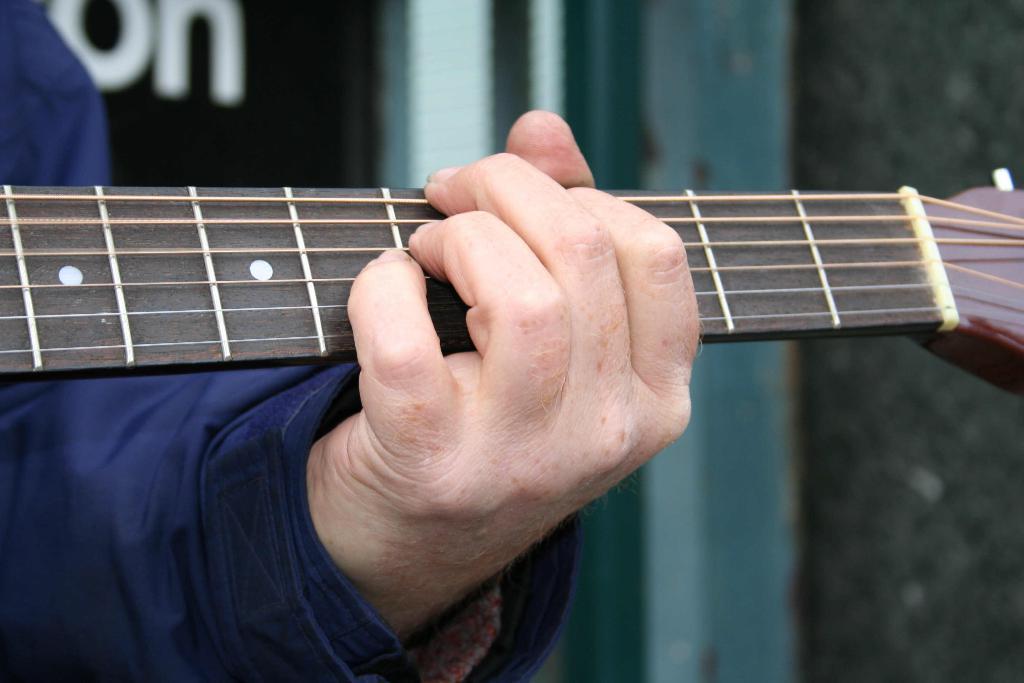Please provide a concise description of this image. In this image I can see only a person's hand holding a guitar. The person is wearing blue color shirt. In the background I can see a wall. 